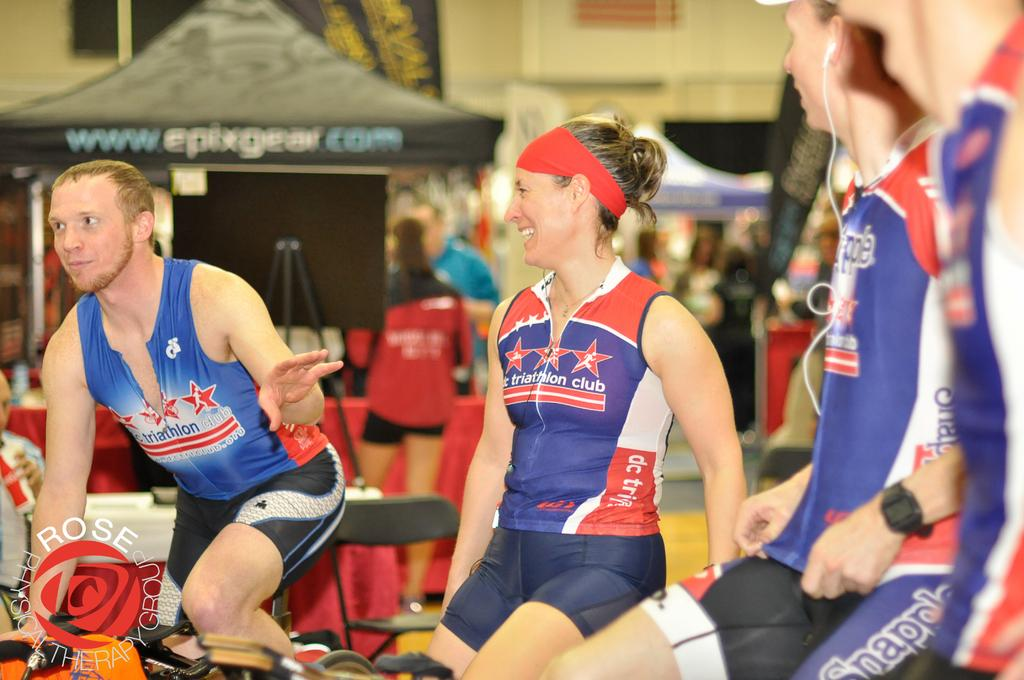<image>
Offer a succinct explanation of the picture presented. the word club on a person's outfit that is blue and red 